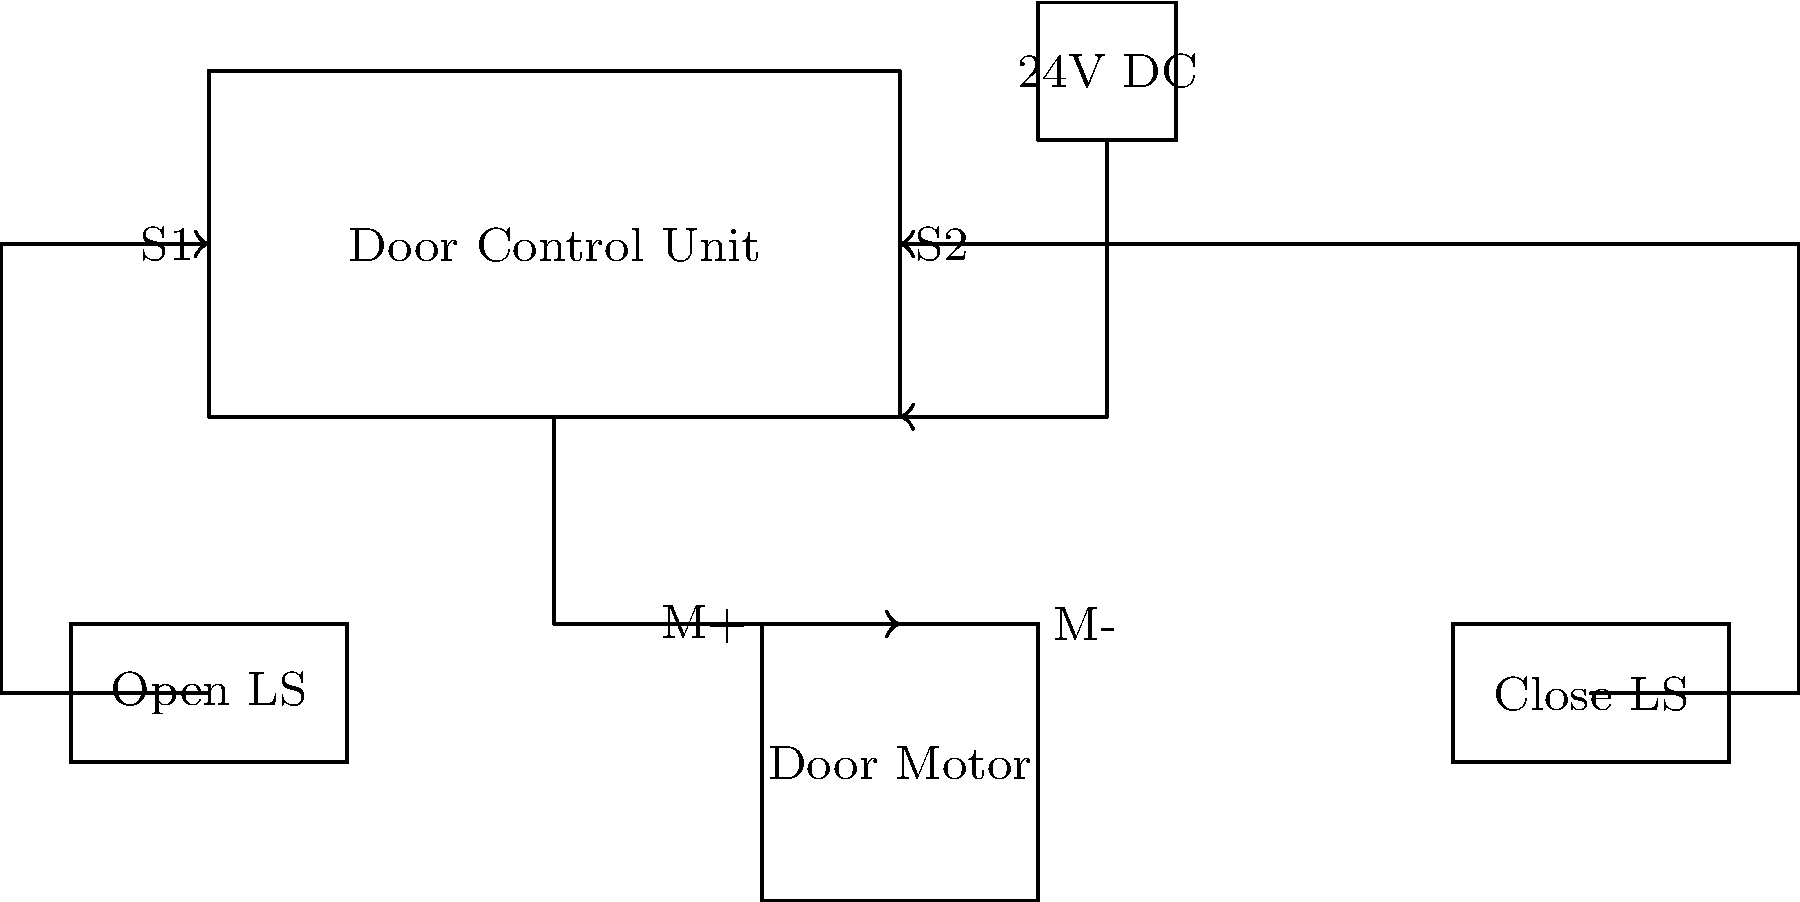In the given circuit diagram of a train's automatic door control system, what is the purpose of the limit switches labeled "Open LS" and "Close LS", and how do they contribute to the safe operation of the door system? To understand the purpose of the limit switches in this automatic door control system, let's break down their function step-by-step:

1. Position indication: The "Open LS" (Open Limit Switch) and "Close LS" (Close Limit Switch) are positioned at the extremes of the door's travel.

2. Door status feedback: 
   - The "Open LS" activates when the door is fully open.
   - The "Close LS" activates when the door is fully closed.

3. Circuit completion: When activated, these switches complete a circuit back to the Door Control Unit (DCU).

4. Motor control:
   - When "Open LS" is activated, it signals the DCU to stop the door motor, preventing over-travel in the open direction.
   - When "Close LS" is activated, it signals the DCU to stop the door motor, ensuring the door is fully closed.

5. Safety function: By preventing over-travel, the limit switches protect the door mechanism from damage and ensure passenger safety.

6. Energy efficiency: Stopping the motor at the right position prevents unnecessary power consumption.

7. System monitoring: The DCU can use the limit switch signals to monitor the door's position and detect any malfunctions.

8. Fail-safe operation: If a limit switch fails, the DCU can use other methods (like current sensing or timing) to infer the door's position, ensuring continued safe operation.

These limit switches are crucial components that provide essential feedback to the Door Control Unit, enabling precise control and safe operation of the train's automatic door system.
Answer: The limit switches provide door position feedback, prevent over-travel, ensure safety, and enable precise motor control. 